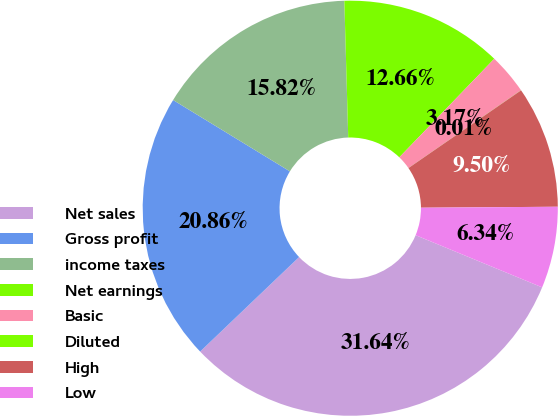<chart> <loc_0><loc_0><loc_500><loc_500><pie_chart><fcel>Net sales<fcel>Gross profit<fcel>income taxes<fcel>Net earnings<fcel>Basic<fcel>Diluted<fcel>High<fcel>Low<nl><fcel>31.64%<fcel>20.86%<fcel>15.82%<fcel>12.66%<fcel>3.17%<fcel>0.01%<fcel>9.5%<fcel>6.34%<nl></chart> 